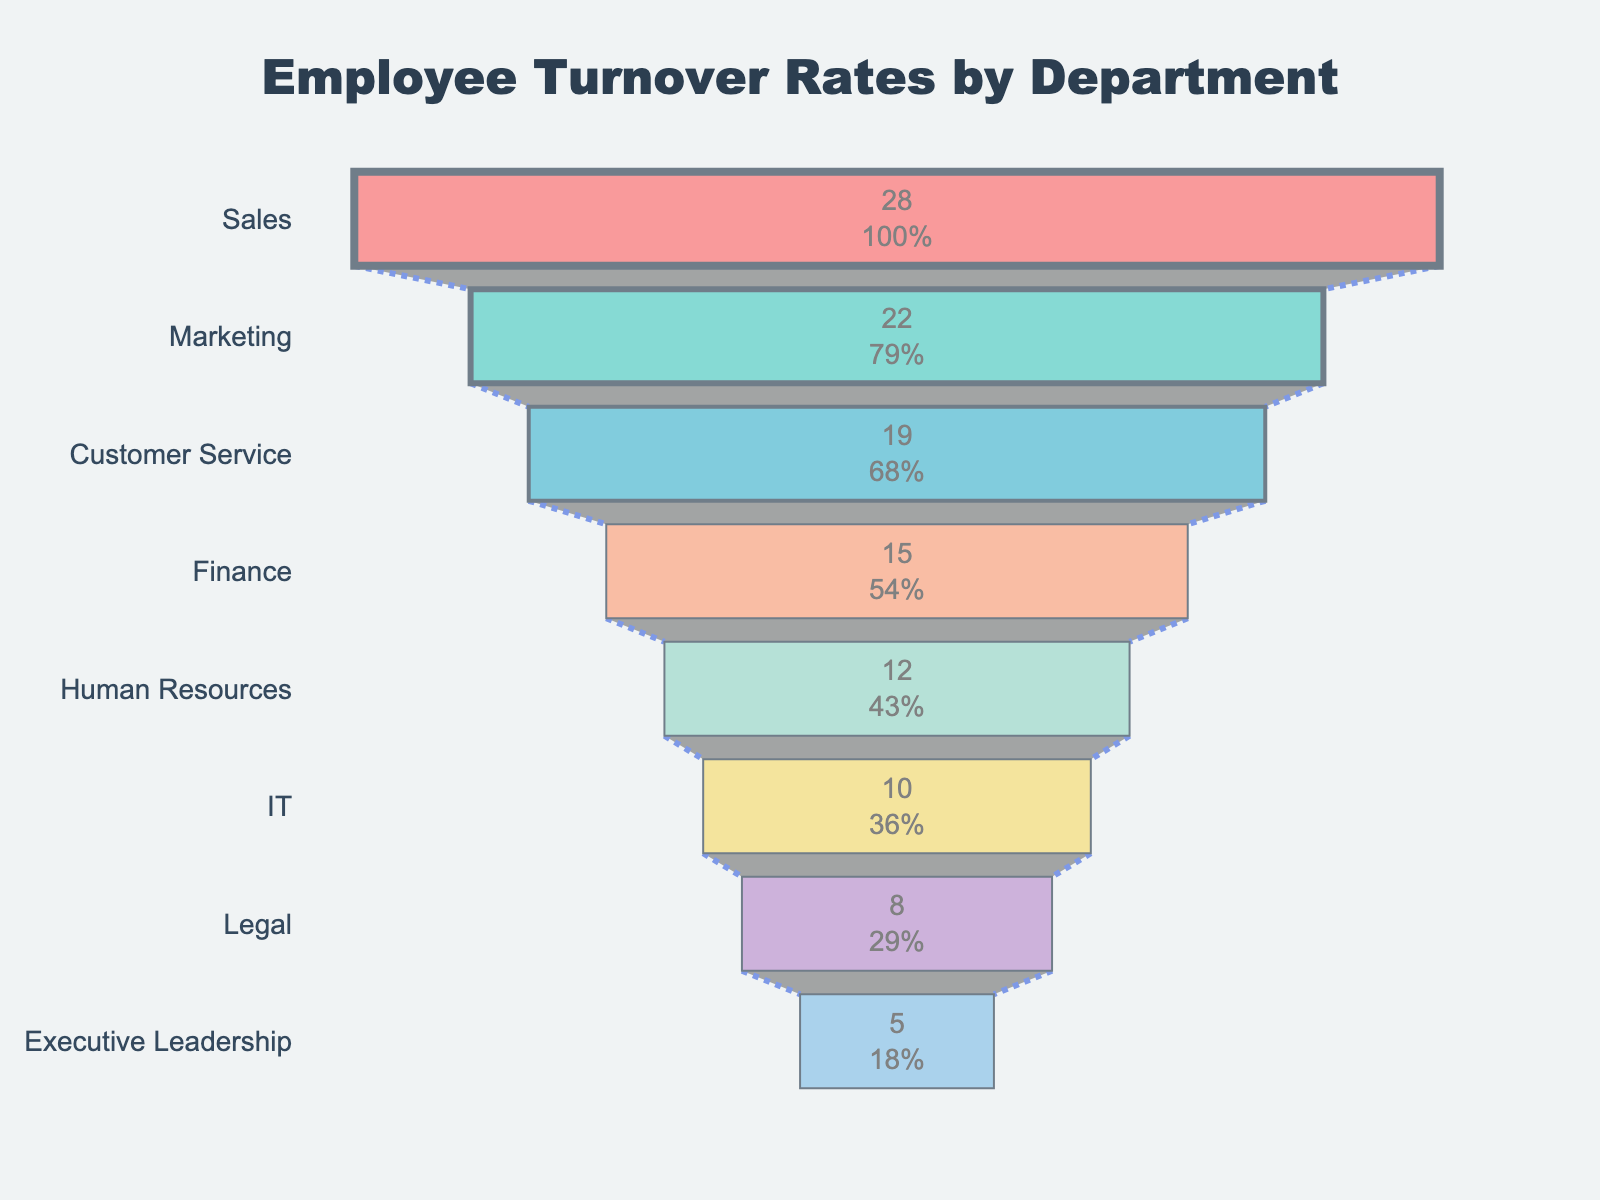What's the title of this chart? The title of a chart is typically found at the top and provides a brief description of the data visualization.
Answer: Employee Turnover Rates by Department Which department has the highest turnover rate? The department with the widest part of the funnel at the top represents the highest turnover rate.
Answer: Sales How much higher is the turnover rate in the Sales department compared to Marketing? By looking at the values, subtract the turnover rate of Marketing from that of Sales: 28% - 22% = 6%.
Answer: 6% What is the total number of departments shown in the chart? Count the distinct department names listed on the y-axis of the funnel chart.
Answer: 8 Which department has a lower turnover rate: IT or Finance? Compare the values of IT and Finance displayed to identify the lower rate.
Answer: IT If the company's average overall turnover rate is 17%, how many departments are below this average? Observe the departments listed with their turnover rates and count those that have a turnover rate of less than 17%.
Answer: 4 What is the turnover rate range in the chart? Determine the difference between the highest and lowest turnover rates: 28% (Sales) - 5% (Executive Leadership) = 23%.
Answer: 23% How do the turnover rates of customer-facing departments (Sales, Marketing, Customer Service) compare to non-customer-facing departments (Finance, HR, IT, Legal, Executive Leadership)? List the turnover rates for each group and calculate the average for customer-facing and non-customer-facing departments, then compare the averages. Customer-facing: (28% + 22% + 19%) / 3 = 23%. Non-customer-facing: (15% + 12% + 10% + 8% + 5%) / 5 = 10%. 23% - 10% = 13%
Answer: 13% What percent of the total distribution does the IT department represent? To find this, adjust the percentages into fractions of the whole and calculate IT's proportion of the total turnover distribution by comparing its rate to the sum of all department turnover rates. IT Department: 10%. Total across all departments: 28% + 22% + 19% + 15% + 12% + 10% + 8% + 5% = 119%. 10% / 119% ≈ 8.4%.
Answer: 8.4% What turnover rate does the annotation highlight in its commentary? The annotation explicitly comments on higher turnover rates, focusing on customer-facing departments at the top of the funnel.
Answer: Higher turnover rates in customer-facing departments 